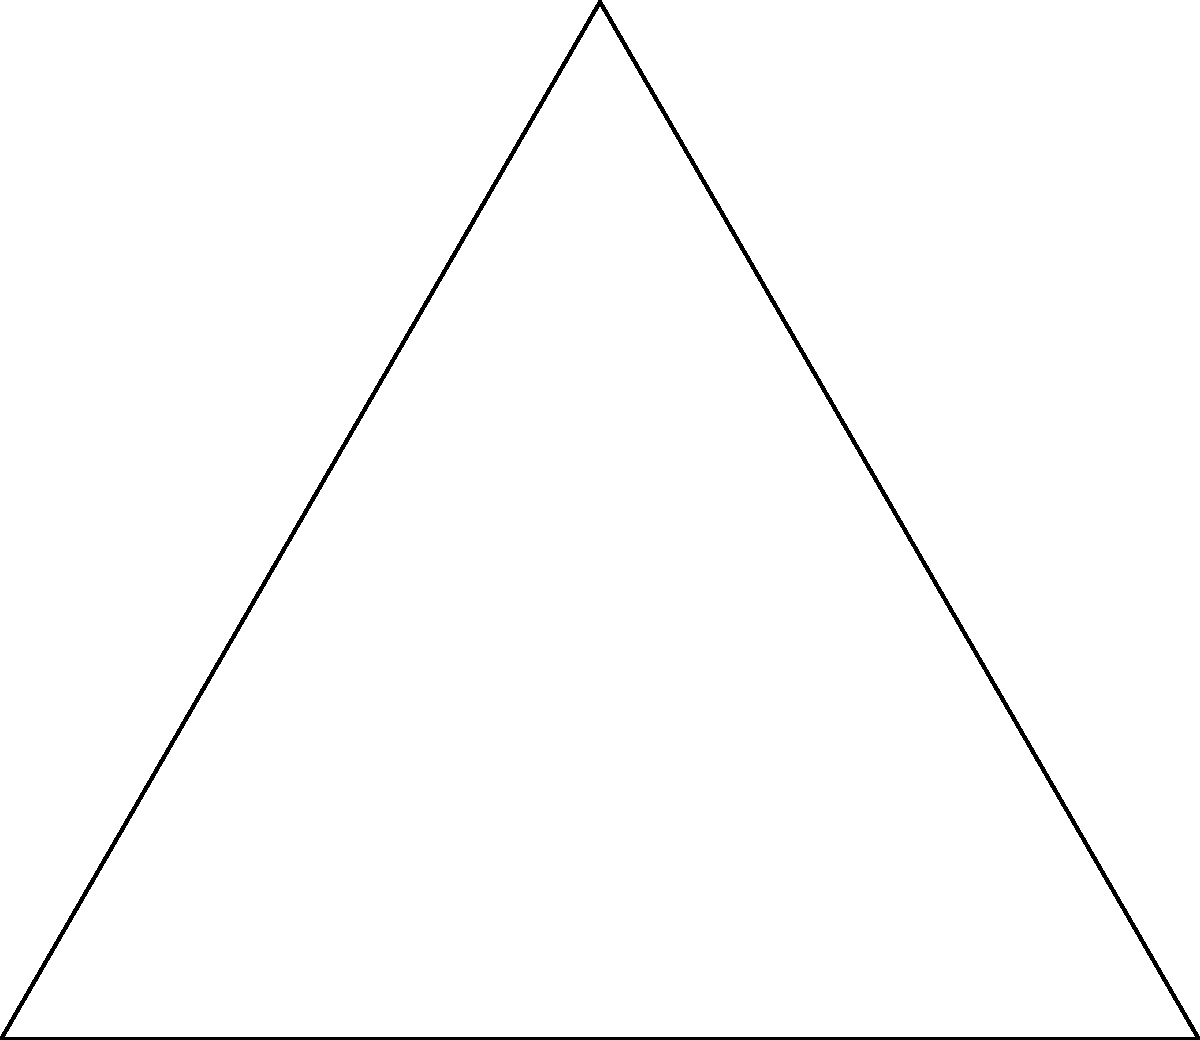Consider the dihedral group $D_3$, represented by the symmetries of an equilateral triangle. In the diagram, $e$ represents the identity, $r$ represents a 120° rotation clockwise, and $s$ represents a reflection across the vertical axis. What is the order of the element $sr$ in $D_3$? To find the order of $sr$ in $D_3$, we need to determine the smallest positive integer $n$ such that $(sr)^n = e$, where $e$ is the identity element. Let's follow these steps:

1) First, let's calculate $(sr)^2$:
   $(sr)(sr) = s(rs)r = sr^2s = r$ (since $rs = sr^2$ in $D_3$)

2) Now, let's calculate $(sr)^3$:
   $(sr)^3 = (sr)(sr)^2 = (sr)(r) = sr^2 = s(r^2) = e$

3) We've found that $(sr)^3 = e$, and this is the smallest positive integer power that gives the identity.

Therefore, the order of $sr$ in $D_3$ is 3.
Answer: 3 